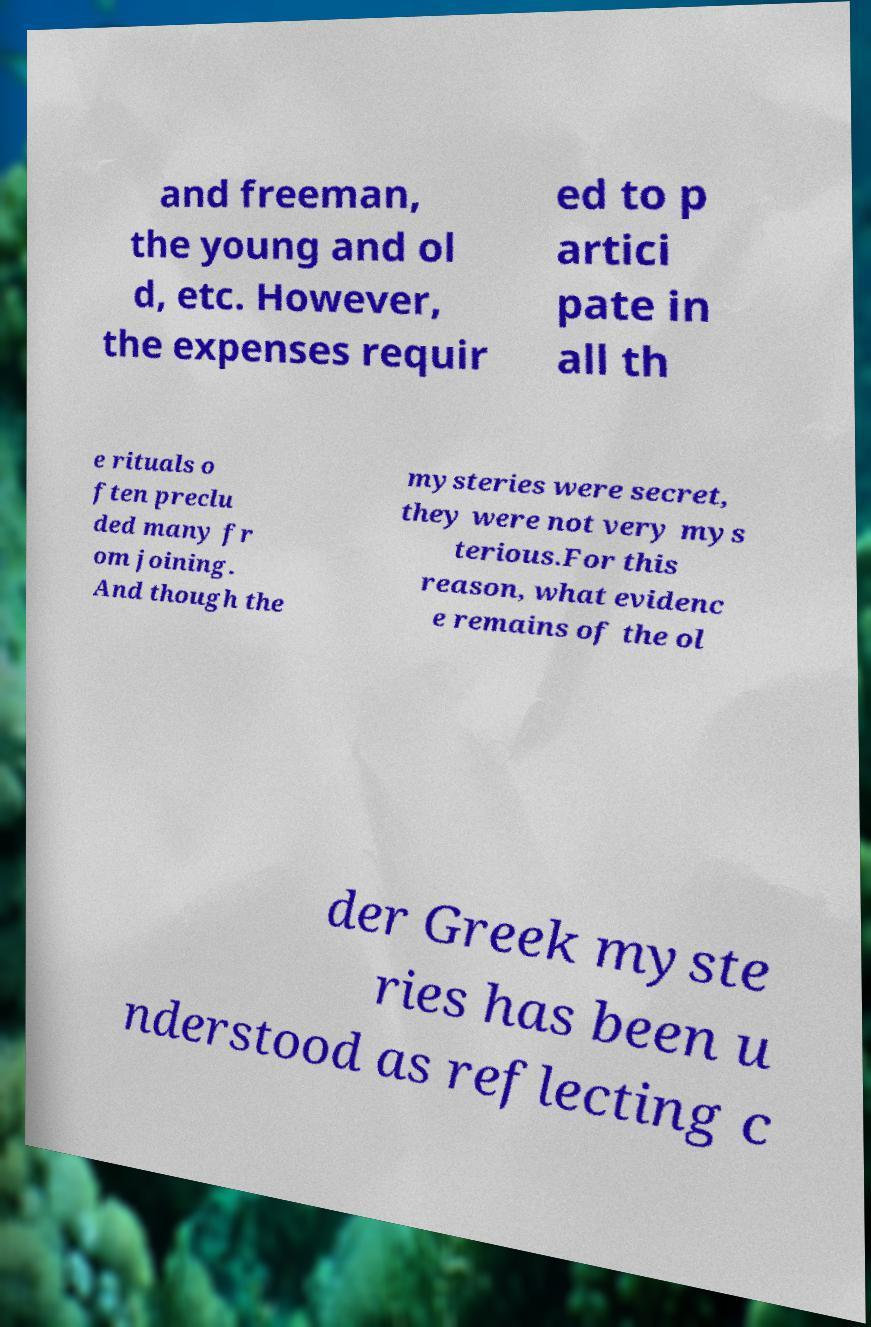Could you assist in decoding the text presented in this image and type it out clearly? and freeman, the young and ol d, etc. However, the expenses requir ed to p artici pate in all th e rituals o ften preclu ded many fr om joining. And though the mysteries were secret, they were not very mys terious.For this reason, what evidenc e remains of the ol der Greek myste ries has been u nderstood as reflecting c 